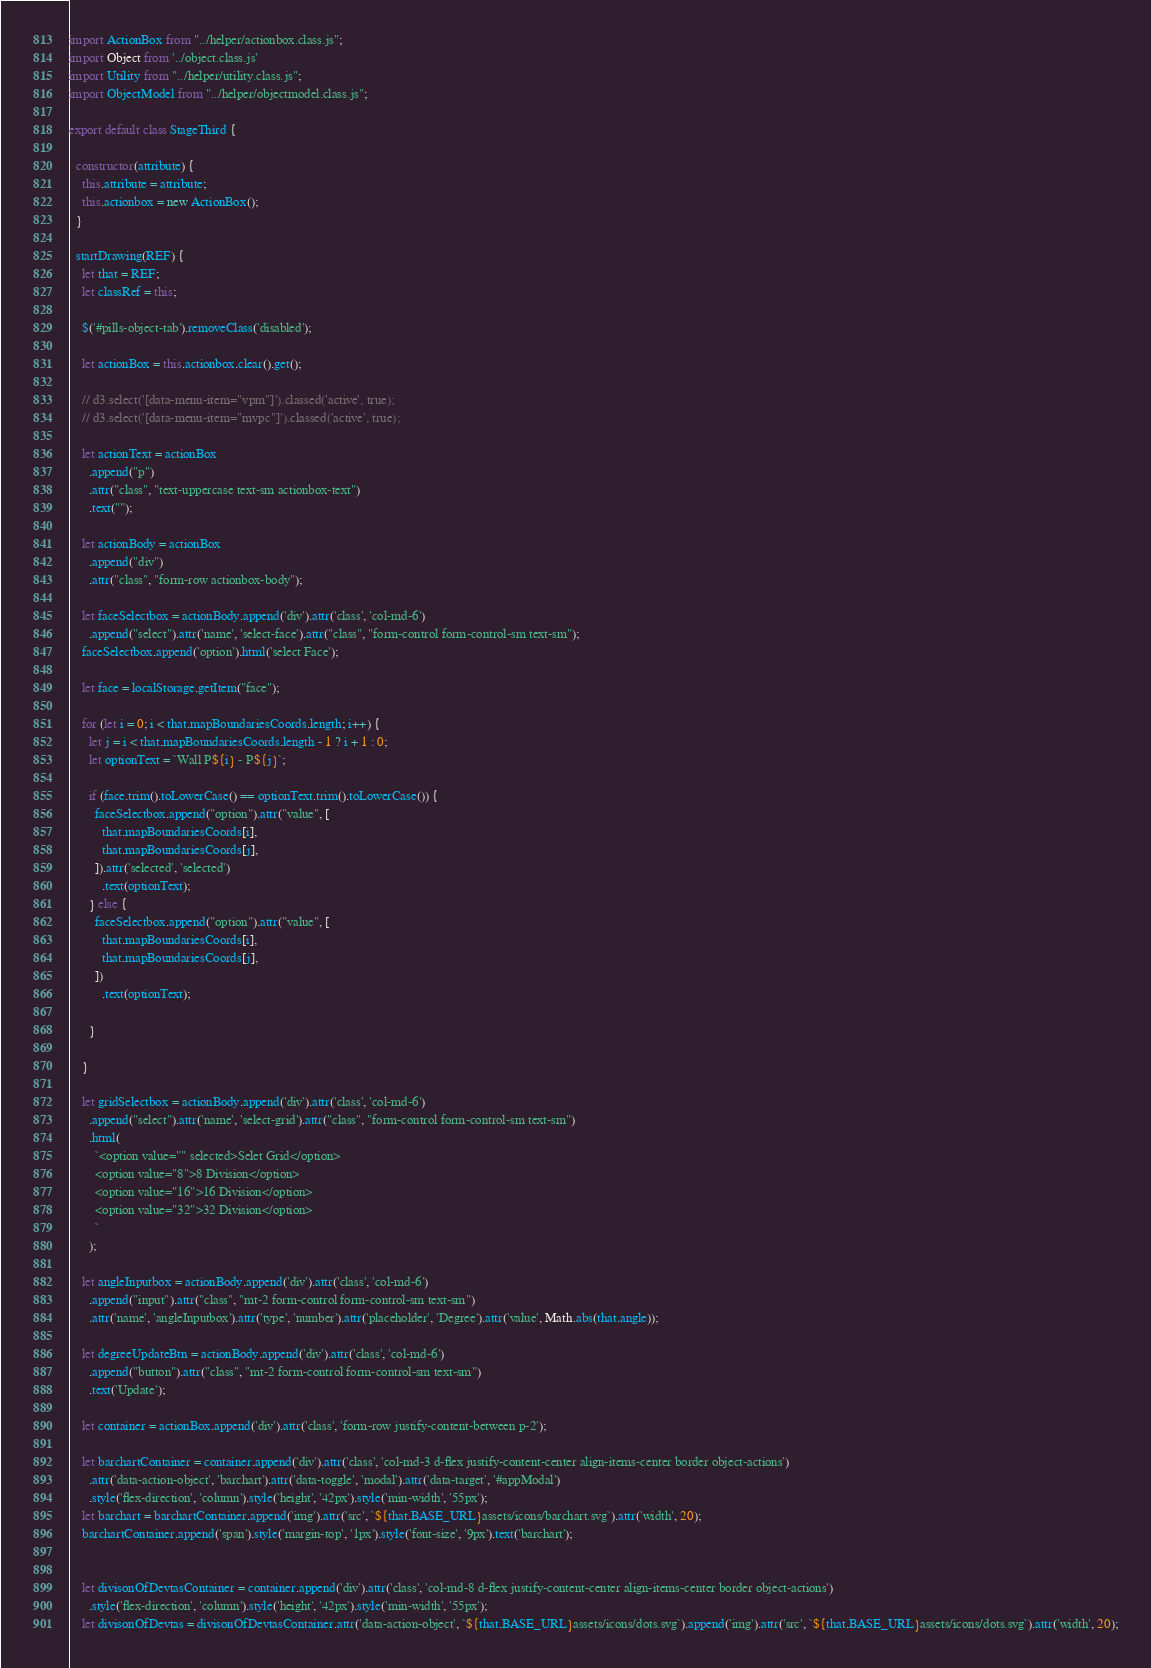<code> <loc_0><loc_0><loc_500><loc_500><_JavaScript_>import ActionBox from "../helper/actionbox.class.js";
import Object from '../object.class.js'
import Utility from "../helper/utility.class.js";
import ObjectModel from "../helper/objectmodel.class.js";

export default class StageThird {

  constructor(attribute) {
    this.attribute = attribute;
    this.actionbox = new ActionBox();
  }

  startDrawing(REF) {
    let that = REF;
    let classRef = this;

    $('#pills-object-tab').removeClass('disabled');

    let actionBox = this.actionbox.clear().get();

    // d3.select('[data-menu-item="vpm"]').classed('active', true);
    // d3.select('[data-menu-item="mvpc"]').classed('active', true);

    let actionText = actionBox
      .append("p")
      .attr("class", "text-uppercase text-sm actionbox-text")
      .text("");

    let actionBody = actionBox
      .append("div")
      .attr("class", "form-row actionbox-body");

    let faceSelectbox = actionBody.append('div').attr('class', 'col-md-6')
      .append("select").attr('name', 'select-face').attr("class", "form-control form-control-sm text-sm");
    faceSelectbox.append('option').html('select Face');

    let face = localStorage.getItem("face");

    for (let i = 0; i < that.mapBoundariesCoords.length; i++) {
      let j = i < that.mapBoundariesCoords.length - 1 ? i + 1 : 0;
      let optionText = `Wall P${i} - P${j}`;

      if (face.trim().toLowerCase() == optionText.trim().toLowerCase()) {
        faceSelectbox.append("option").attr("value", [
          that.mapBoundariesCoords[i],
          that.mapBoundariesCoords[j],
        ]).attr('selected', 'selected')
          .text(optionText);
      } else {
        faceSelectbox.append("option").attr("value", [
          that.mapBoundariesCoords[i],
          that.mapBoundariesCoords[j],
        ])
          .text(optionText);

      }

    }

    let gridSelectbox = actionBody.append('div').attr('class', 'col-md-6')
      .append("select").attr('name', 'select-grid').attr("class", "form-control form-control-sm text-sm")
      .html(
        `<option value="" selected>Selet Grid</option>
        <option value="8">8 Division</option>
        <option value="16">16 Division</option>
        <option value="32">32 Division</option>
        `
      );

    let angleInputbox = actionBody.append('div').attr('class', 'col-md-6')
      .append("input").attr("class", "mt-2 form-control form-control-sm text-sm")
      .attr('name', 'angleInputbox').attr('type', 'number').attr('placeholder', 'Degree').attr('value', Math.abs(that.angle));

    let degreeUpdateBtn = actionBody.append('div').attr('class', 'col-md-6')
      .append("button").attr("class", "mt-2 form-control form-control-sm text-sm")
      .text('Update');

    let container = actionBox.append('div').attr('class', 'form-row justify-content-between p-2');

    let barchartContainer = container.append('div').attr('class', 'col-md-3 d-flex justify-content-center align-items-center border object-actions')
      .attr('data-action-object', 'barchart').attr('data-toggle', 'modal').attr('data-target', '#appModal')
      .style('flex-direction', 'column').style('height', '42px').style('min-width', '55px');
    let barchart = barchartContainer.append('img').attr('src', `${that.BASE_URL}assets/icons/barchart.svg`).attr('width', 20);
    barchartContainer.append('span').style('margin-top', '1px').style('font-size', '9px').text('barchart');


    let divisonOfDevtasContainer = container.append('div').attr('class', 'col-md-8 d-flex justify-content-center align-items-center border object-actions')
      .style('flex-direction', 'column').style('height', '42px').style('min-width', '55px');
    let divisonOfDevtas = divisonOfDevtasContainer.attr('data-action-object', `${that.BASE_URL}assets/icons/dots.svg`).append('img').attr('src', `${that.BASE_URL}assets/icons/dots.svg`).attr('width', 20);</code> 